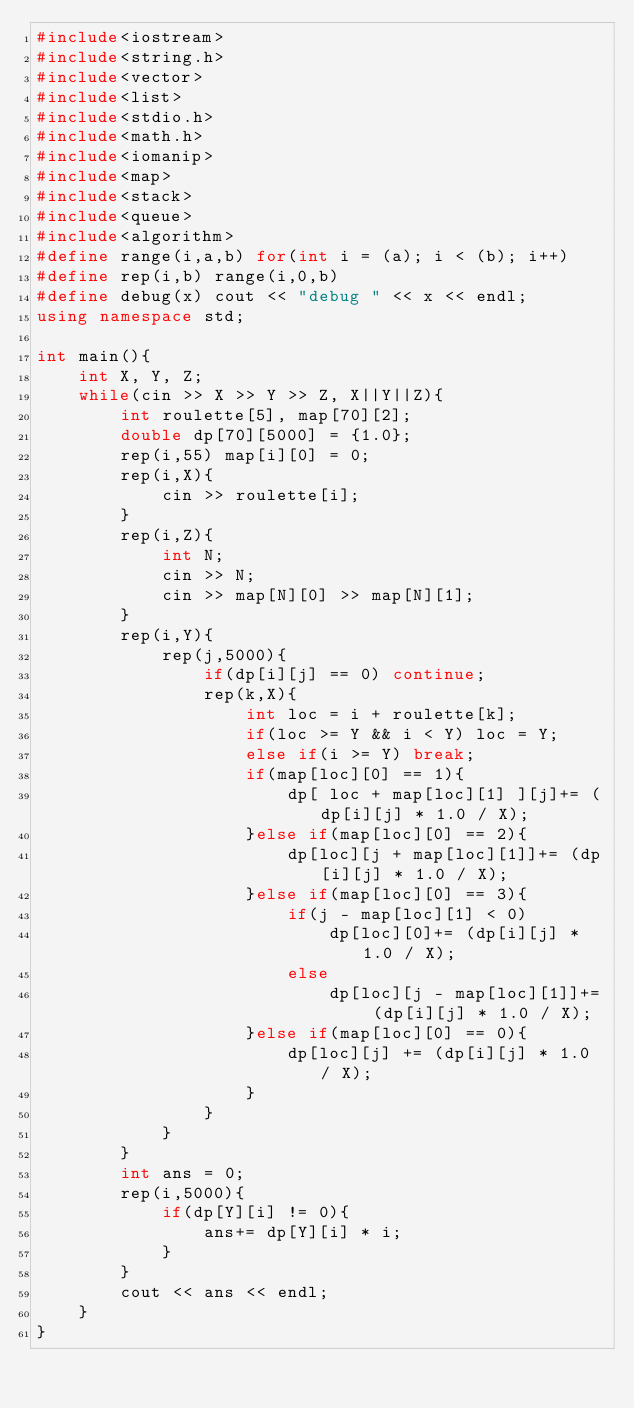<code> <loc_0><loc_0><loc_500><loc_500><_C++_>#include<iostream>
#include<string.h>
#include<vector>
#include<list>
#include<stdio.h>
#include<math.h>
#include<iomanip>
#include<map>
#include<stack>
#include<queue>
#include<algorithm>
#define range(i,a,b) for(int i = (a); i < (b); i++)
#define rep(i,b) range(i,0,b)
#define debug(x) cout << "debug " << x << endl;
using namespace std;

int main(){
    int X, Y, Z;
    while(cin >> X >> Y >> Z, X||Y||Z){
        int roulette[5], map[70][2];
        double dp[70][5000] = {1.0};
        rep(i,55) map[i][0] = 0;
        rep(i,X){
            cin >> roulette[i];
        }
        rep(i,Z){
            int N;
            cin >> N;
            cin >> map[N][0] >> map[N][1];
        }
        rep(i,Y){
            rep(j,5000){
                if(dp[i][j] == 0) continue;
                rep(k,X){
                    int loc = i + roulette[k];
                    if(loc >= Y && i < Y) loc = Y;
                    else if(i >= Y) break;
                    if(map[loc][0] == 1){
                        dp[ loc + map[loc][1] ][j]+= (dp[i][j] * 1.0 / X);
                    }else if(map[loc][0] == 2){
                        dp[loc][j + map[loc][1]]+= (dp[i][j] * 1.0 / X);
                    }else if(map[loc][0] == 3){
                        if(j - map[loc][1] < 0)
                            dp[loc][0]+= (dp[i][j] * 1.0 / X);
                        else
                            dp[loc][j - map[loc][1]]+= (dp[i][j] * 1.0 / X);
                    }else if(map[loc][0] == 0){
                        dp[loc][j] += (dp[i][j] * 1.0 / X);
                    }
                }
            }
        }
        int ans = 0;
        rep(i,5000){
            if(dp[Y][i] != 0){
                ans+= dp[Y][i] * i;
            }
        }
        cout << ans << endl;
    }
}</code> 